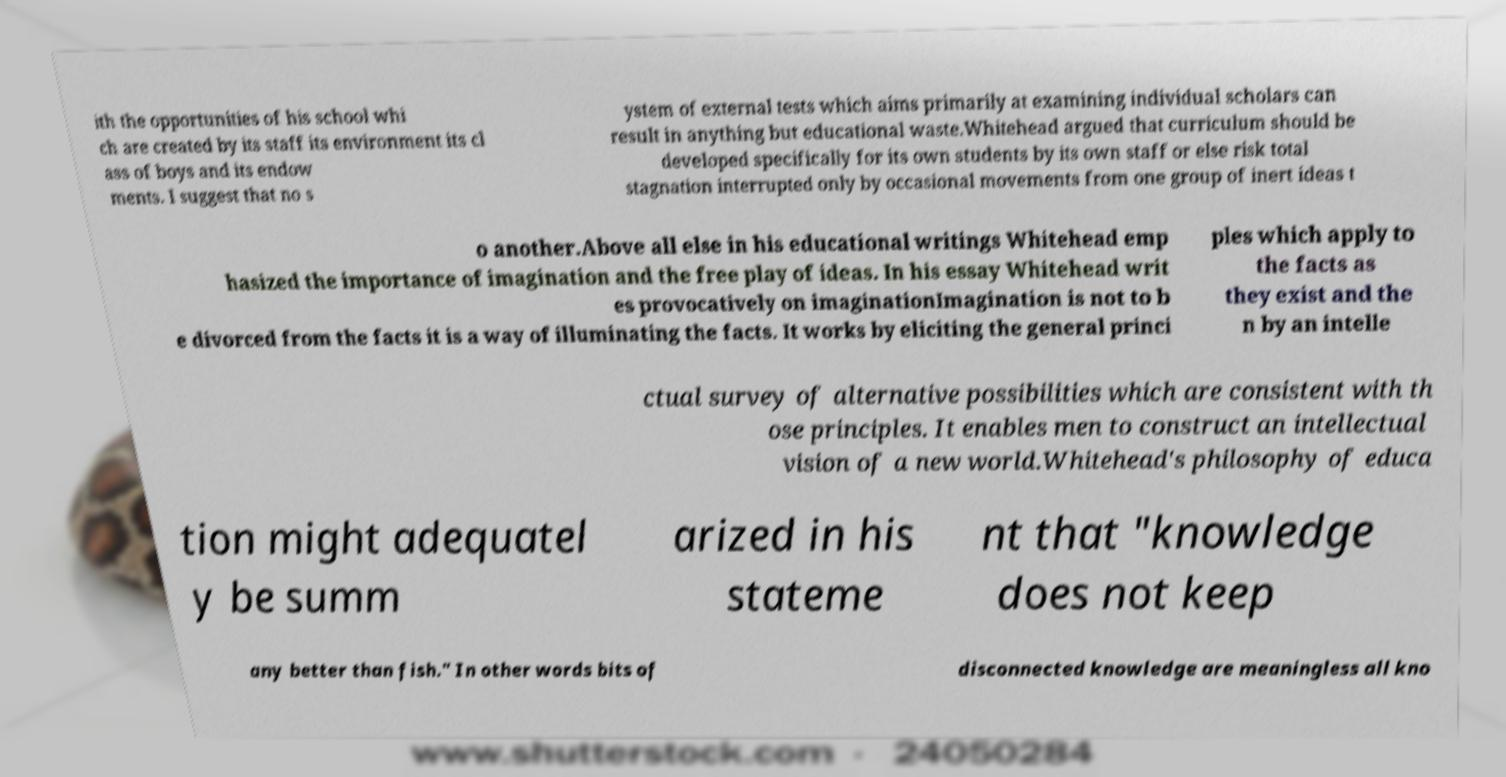Please identify and transcribe the text found in this image. ith the opportunities of his school whi ch are created by its staff its environment its cl ass of boys and its endow ments. I suggest that no s ystem of external tests which aims primarily at examining individual scholars can result in anything but educational waste.Whitehead argued that curriculum should be developed specifically for its own students by its own staff or else risk total stagnation interrupted only by occasional movements from one group of inert ideas t o another.Above all else in his educational writings Whitehead emp hasized the importance of imagination and the free play of ideas. In his essay Whitehead writ es provocatively on imaginationImagination is not to b e divorced from the facts it is a way of illuminating the facts. It works by eliciting the general princi ples which apply to the facts as they exist and the n by an intelle ctual survey of alternative possibilities which are consistent with th ose principles. It enables men to construct an intellectual vision of a new world.Whitehead's philosophy of educa tion might adequatel y be summ arized in his stateme nt that "knowledge does not keep any better than fish." In other words bits of disconnected knowledge are meaningless all kno 